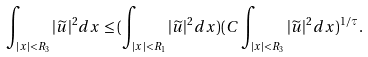Convert formula to latex. <formula><loc_0><loc_0><loc_500><loc_500>\int _ { | x | < { R _ { 3 } } } | \widetilde { u } | ^ { 2 } d x \leq ( \int _ { | x | < { R _ { 1 } } } | \widetilde { u } | ^ { 2 } d x ) ( C \int _ { | x | < { R _ { 3 } } } | \widetilde { u } | ^ { 2 } d x ) ^ { 1 / \tau } .</formula> 